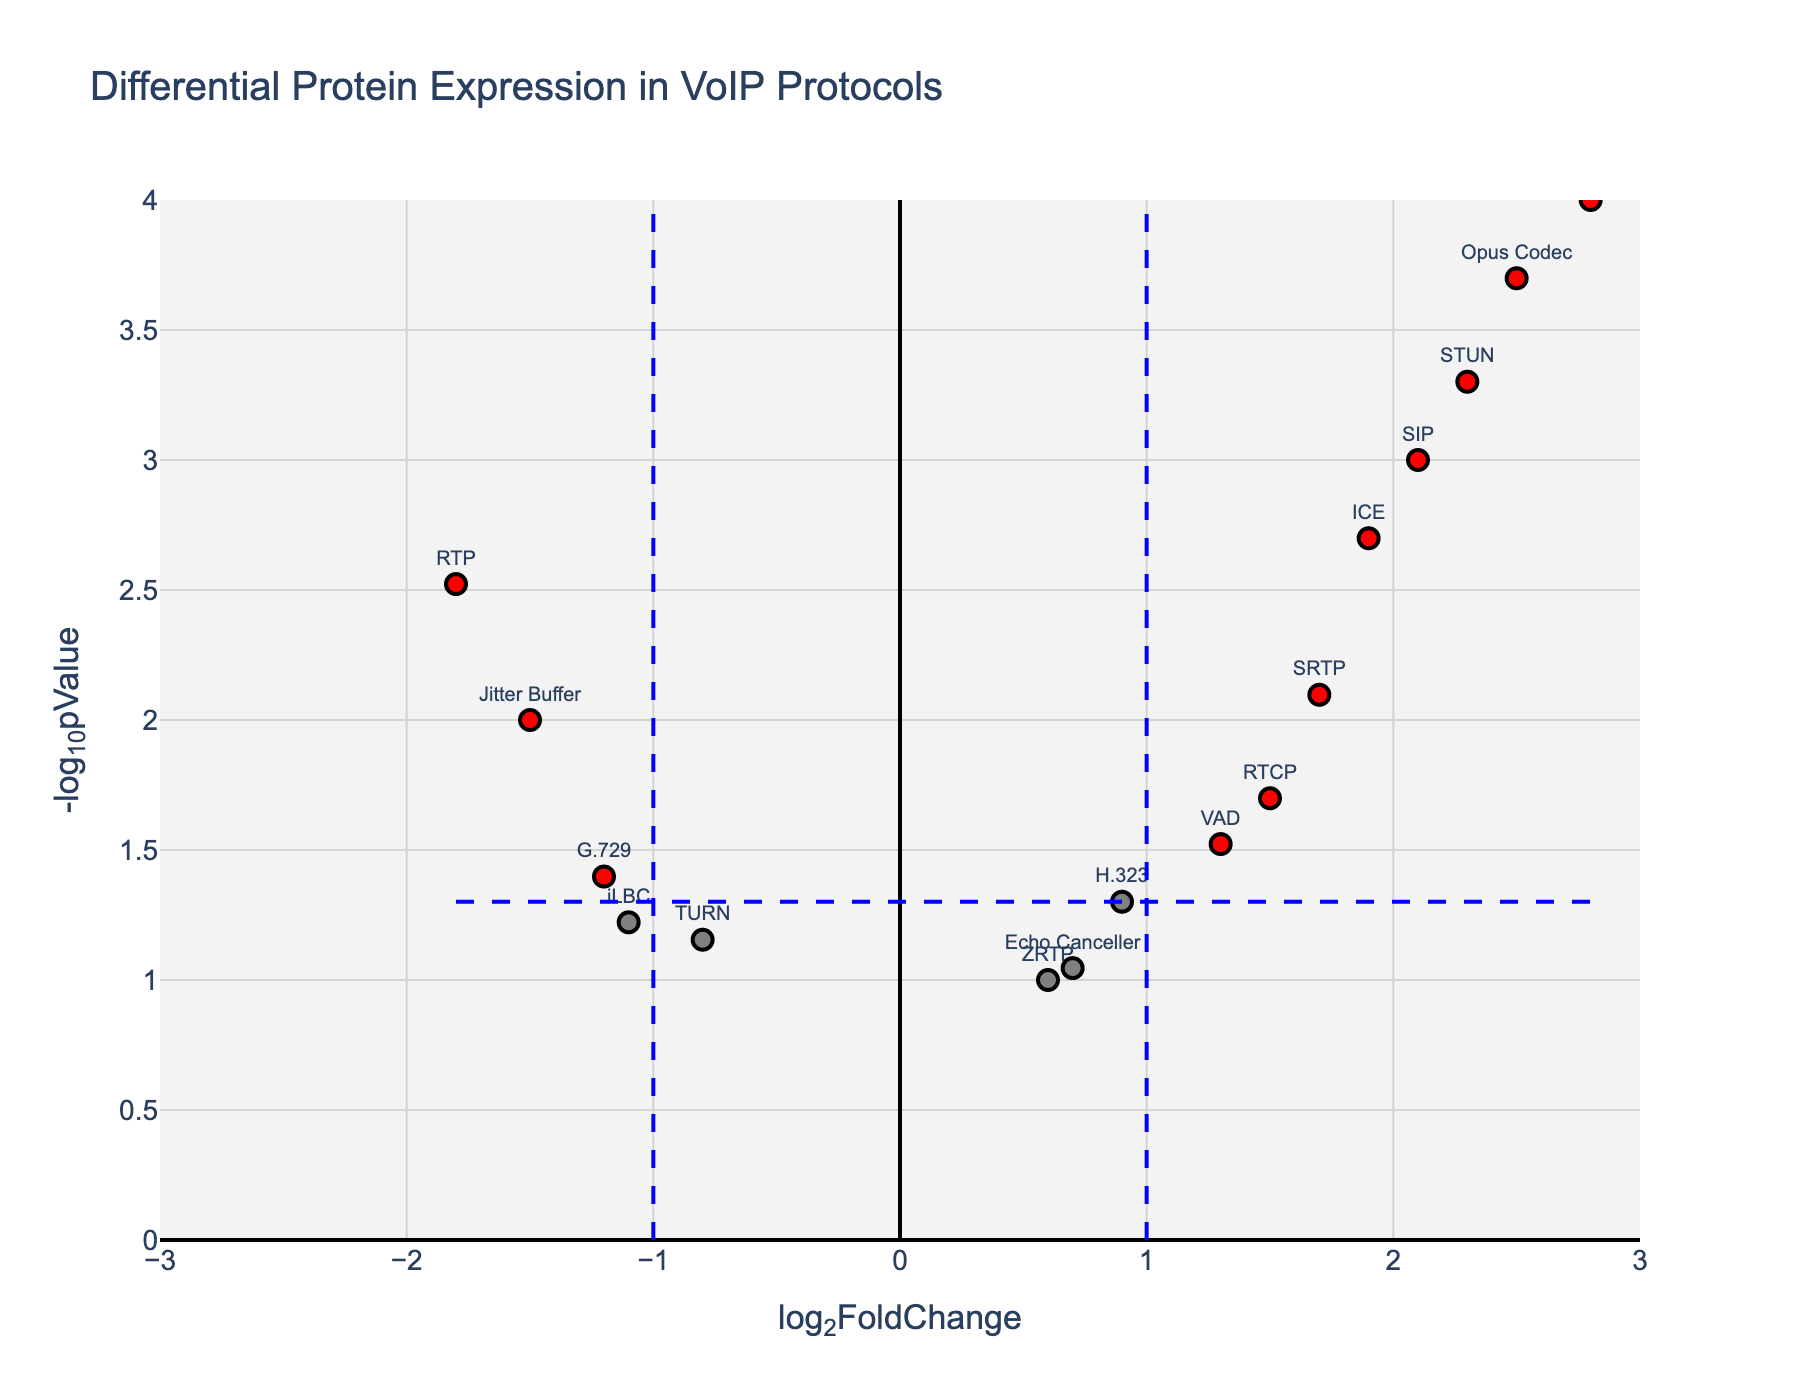What is the title of the figure? The title is usually displayed prominently at the top of the plot. It helps to understand the context of the plot without delving into specific data points.
Answer: Differential Protein Expression in VoIP Protocols How many data points are shown in the plot? To answer this, count the number of markers representing data points in the figure directly. Each protein has a corresponding point on the plot.
Answer: 16 Which protein has the highest -log10pValue? Locate the highest point on the y-axis representing the -log10pValue. The protein label corresponding to this point will have the highest value.
Answer: G.711 Which proteins have log2FoldChange greater than 2? Look for data points that are positioned to the right of the log2FoldChange threshold of 2 on the x-axis. These points correspond to proteins with a higher fold change.
Answer: G.711, Opus Codec, STUN Which data point indicates the most significant upregulation (highest log2FoldChange with a low p-value)? Identify the point with the highest positive log2FoldChange and a low corresponding p-value (high -log10pValue).
Answer: G.711 How many proteins have a log2FoldChange below -1 and are statistically significant? First, filter for points on the left side of the -1 log2FoldChange threshold. Then check if their -log10pValue is above the threshold line for significance (e.g., 1.3 for p = 0.05).
Answer: 3 (RTP, G.729, Jitter Buffer) What visual threshold lines can be found in the plot, and what do they signify? Identify and explain the significance of the dashed lines. Usually, horizontal lines represent p-value thresholds, and vertical lines represent fold-change thresholds.
Answer: Blue dashed lines for log2FoldChange at 1 and -1, and for -log10pValue at 1.3 (p = 0.05) Which proteins have a p-value greater than 0.05? Look for data points below the horizontal threshold line at -log10(p-value) of approximately 1.3. These points indicate a higher p-value than the significance level.
Answer: ZRTP, TURN, iLBC, Echo Canceller Are there more upregulated or downregulated significant proteins? Count the number of significant red points on both the right (upregulated) and left (downregulated) sides of the plot. Compare these counts.
Answer: More upregulated What is the log2FoldChange and p-value of the Echo Canceller? Hover over or locate the specific data point for the Echo Canceller. The hover text or label provides both values directly from the plot.
Answer: log2FoldChange = 0.7, p-value = 0.09 